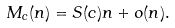Convert formula to latex. <formula><loc_0><loc_0><loc_500><loc_500>M _ { c } ( n ) = S ( c ) n + o ( n ) .</formula> 